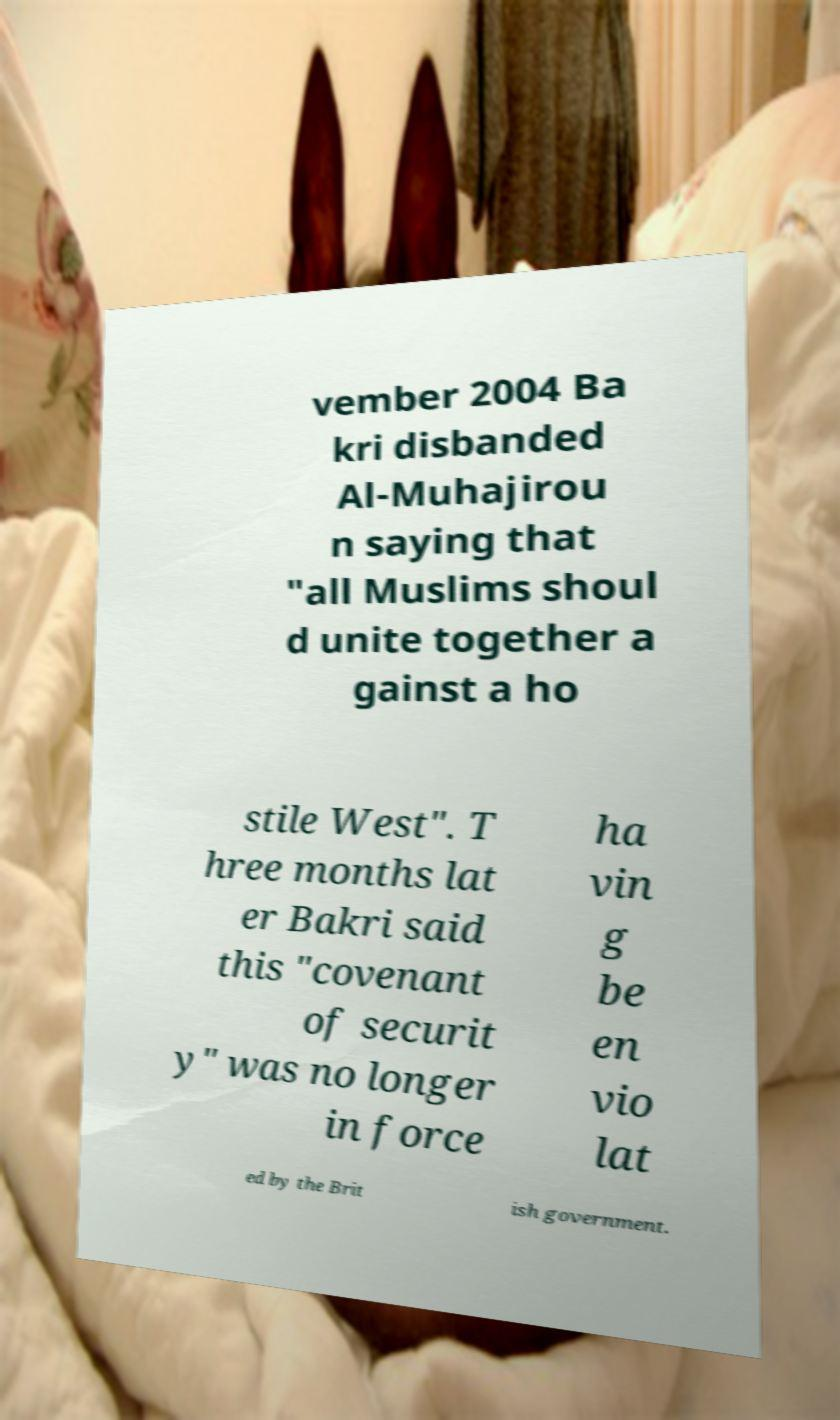What messages or text are displayed in this image? I need them in a readable, typed format. vember 2004 Ba kri disbanded Al-Muhajirou n saying that "all Muslims shoul d unite together a gainst a ho stile West". T hree months lat er Bakri said this "covenant of securit y" was no longer in force ha vin g be en vio lat ed by the Brit ish government. 